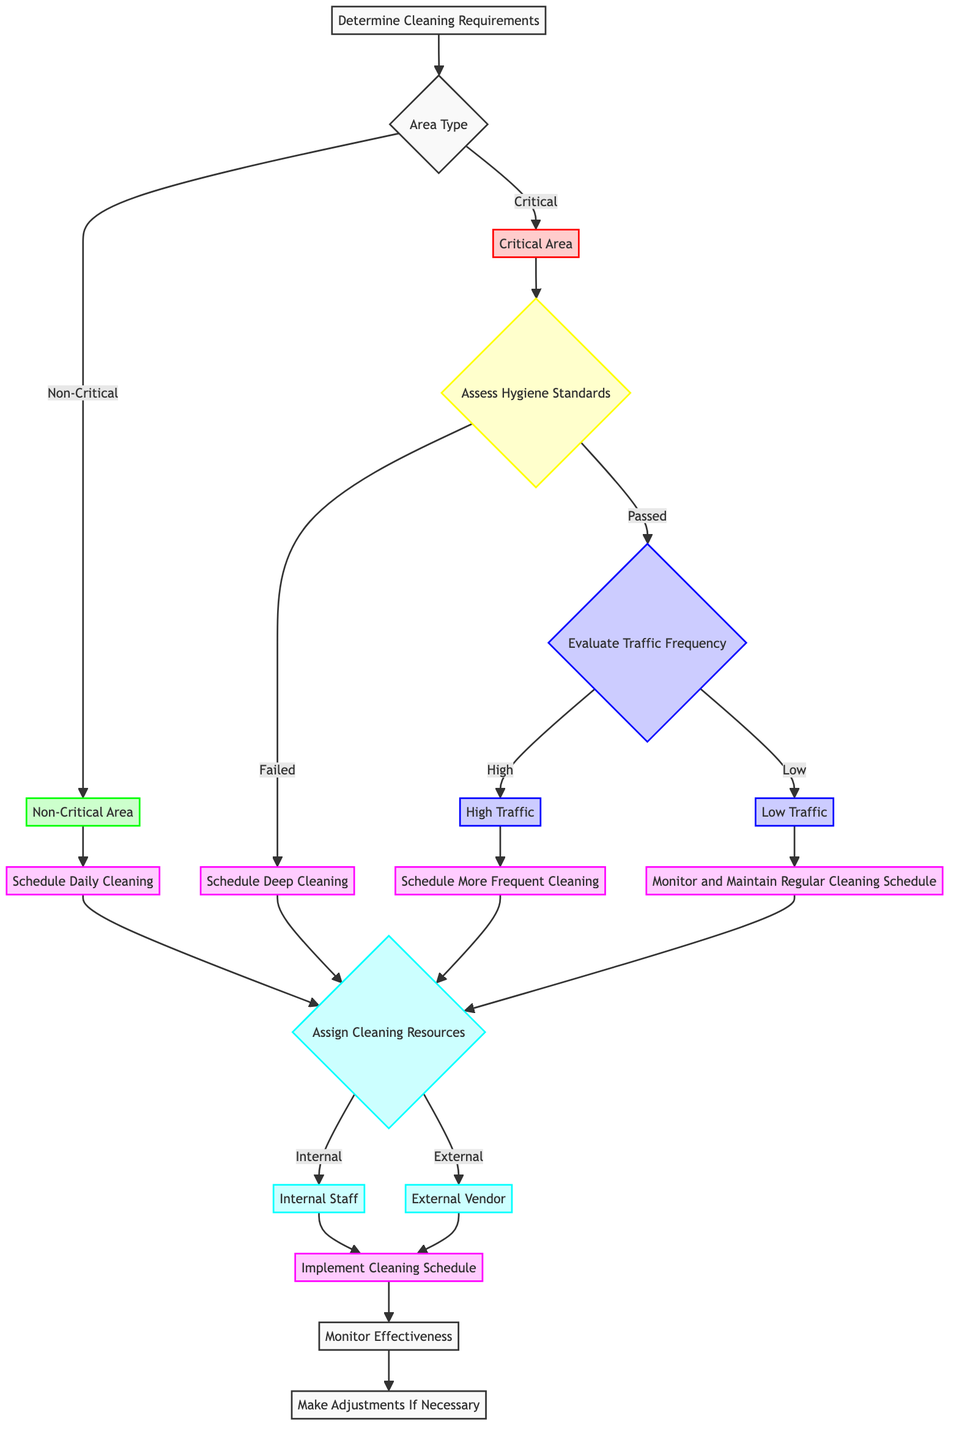What is the starting point of the decision tree? The starting point of the decision tree is labeled as "Determine Cleaning Requirements." This is the first node in the diagram, indicating the initial action to take in the decision-making process.
Answer: Determine Cleaning Requirements How many types of Area Types are there? There are two types of Area Types: Critical Area and Non-Critical Area. Each type represents different levels of risk and leads to different subsequent decisions in the cleaning schedule.
Answer: Two What happens if the hygiene standards are failed? If the hygiene standards are failed, the next step is to "Schedule Deep Cleaning." This indicates that the area does not meet required hygiene levels and requires a thorough cleaning process.
Answer: Schedule Deep Cleaning What is scheduled for High Traffic areas? High Traffic areas are scheduled for "More Frequent Cleaning." This indicates that due to the high volume of usage, these areas require more attention to maintain hygiene.
Answer: Schedule More Frequent Cleaning Which node follows the "Schedule Daily Cleaning"? The node that follows "Schedule Daily Cleaning" is "Assign Cleaning Resources." This means that after deciding the cleaning schedule, the next step is to determine how to allocate resources for the cleaning process.
Answer: Assign Cleaning Resources What are the two options for cleaning resources? The two options for cleaning resources are "Internal Staff" and "External Vendor." This indicates the choice of either using in-house staff or outsourcing the cleaning services.
Answer: Internal Staff or External Vendor What does the "Monitor Effectiveness" node imply? The "Monitor Effectiveness" node implies the need to regularly assess how well the cleaning schedule is working. This step is crucial to ensure that the cleaning measures are effective in maintaining hygiene standards.
Answer: Monitor Effectiveness After monitoring, what can be done if adjustments are needed? If adjustments are needed, the process is to "Make Adjustments If Necessary." This indicates that based on feedback and monitoring results, the cleaning schedule may be modified for better outcomes.
Answer: Make Adjustments If Necessary What type of areas lead to scheduling daily cleaning? Non-Critical Areas lead to scheduling daily cleaning. This indicates that areas deemed as low-risk, such as administrative offices and waiting rooms, can follow a routine cleaning schedule.
Answer: Non-Critical Areas 